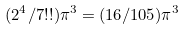<formula> <loc_0><loc_0><loc_500><loc_500>( 2 ^ { 4 } / 7 ! ! ) \pi ^ { 3 } = ( 1 6 / 1 0 5 ) \pi ^ { 3 }</formula> 